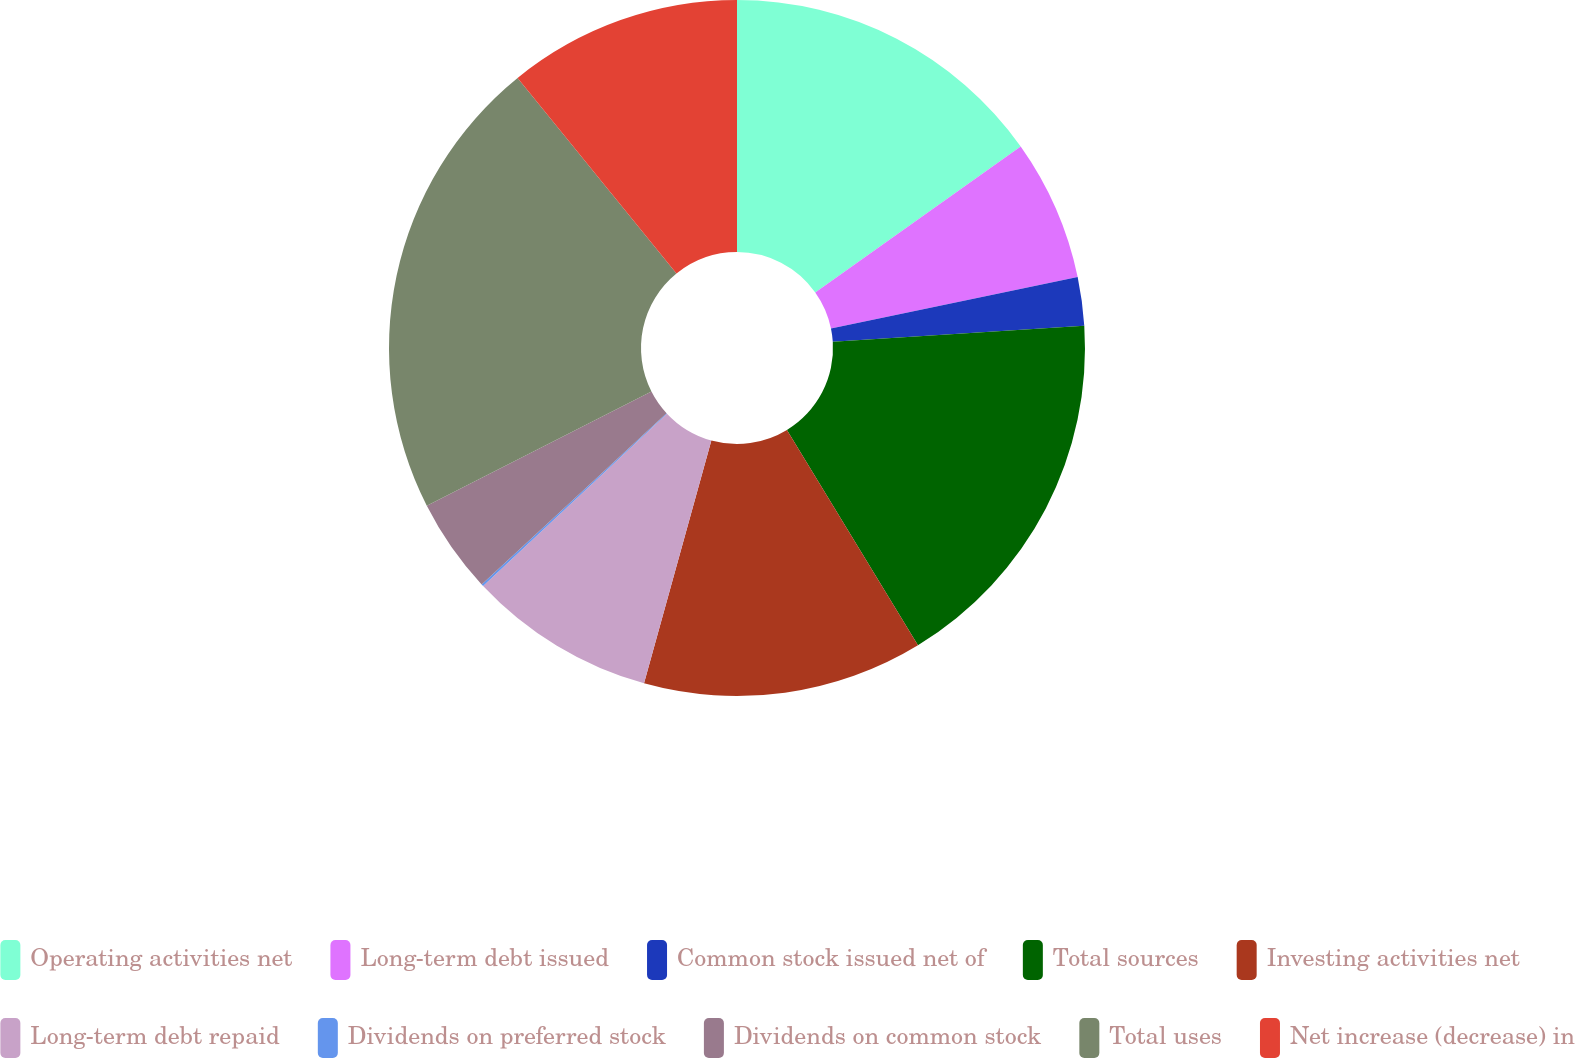<chart> <loc_0><loc_0><loc_500><loc_500><pie_chart><fcel>Operating activities net<fcel>Long-term debt issued<fcel>Common stock issued net of<fcel>Total sources<fcel>Investing activities net<fcel>Long-term debt repaid<fcel>Dividends on preferred stock<fcel>Dividends on common stock<fcel>Total uses<fcel>Net increase (decrease) in<nl><fcel>15.17%<fcel>6.56%<fcel>2.25%<fcel>17.32%<fcel>13.01%<fcel>8.71%<fcel>0.1%<fcel>4.4%<fcel>21.63%<fcel>10.86%<nl></chart> 